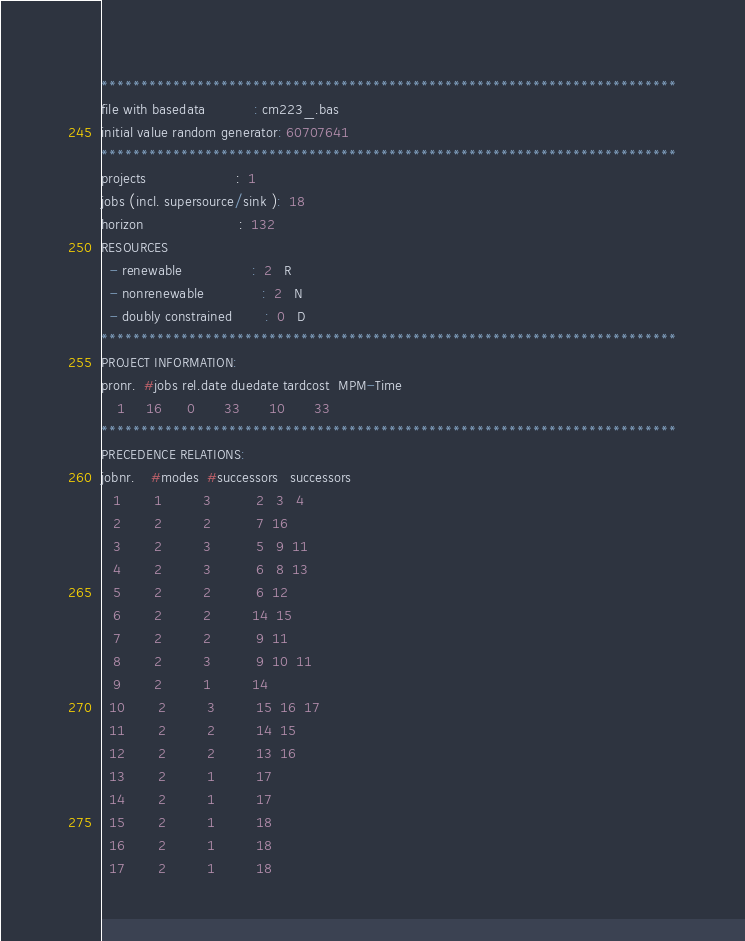<code> <loc_0><loc_0><loc_500><loc_500><_ObjectiveC_>************************************************************************
file with basedata            : cm223_.bas
initial value random generator: 60707641
************************************************************************
projects                      :  1
jobs (incl. supersource/sink ):  18
horizon                       :  132
RESOURCES
  - renewable                 :  2   R
  - nonrenewable              :  2   N
  - doubly constrained        :  0   D
************************************************************************
PROJECT INFORMATION:
pronr.  #jobs rel.date duedate tardcost  MPM-Time
    1     16      0       33       10       33
************************************************************************
PRECEDENCE RELATIONS:
jobnr.    #modes  #successors   successors
   1        1          3           2   3   4
   2        2          2           7  16
   3        2          3           5   9  11
   4        2          3           6   8  13
   5        2          2           6  12
   6        2          2          14  15
   7        2          2           9  11
   8        2          3           9  10  11
   9        2          1          14
  10        2          3          15  16  17
  11        2          2          14  15
  12        2          2          13  16
  13        2          1          17
  14        2          1          17
  15        2          1          18
  16        2          1          18
  17        2          1          18</code> 